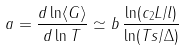Convert formula to latex. <formula><loc_0><loc_0><loc_500><loc_500>a = \frac { d \ln \langle G \rangle } { d \ln T } \simeq b \, \frac { \ln ( c _ { 2 } L / l ) } { \ln ( T s / \Delta ) }</formula> 